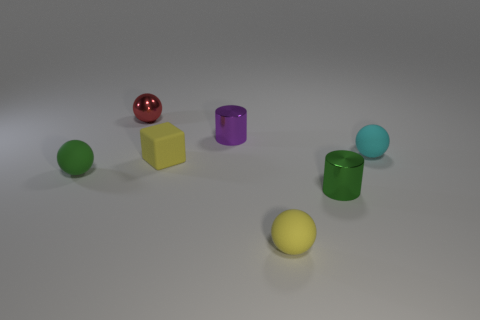There is another metal object that is the same shape as the tiny cyan thing; what is its color?
Offer a very short reply. Red. There is a rubber object that is in front of the matte ball that is on the left side of the red thing; what is its color?
Keep it short and to the point. Yellow. How many green spheres are made of the same material as the purple cylinder?
Offer a very short reply. 0. There is a tiny rubber object that is to the left of the metallic ball; how many tiny red things are to the left of it?
Provide a short and direct response. 0. There is a cyan rubber object; are there any green objects behind it?
Provide a short and direct response. No. Does the small green object that is on the right side of the metallic ball have the same shape as the red metallic thing?
Provide a succinct answer. No. How many cylinders have the same color as the small cube?
Offer a terse response. 0. The tiny yellow thing behind the small green rubber ball that is in front of the small purple thing is what shape?
Provide a succinct answer. Cube. Is there a small metal thing of the same shape as the small cyan rubber thing?
Offer a terse response. Yes. Does the tiny block have the same color as the rubber ball that is in front of the small green rubber sphere?
Provide a short and direct response. Yes. 